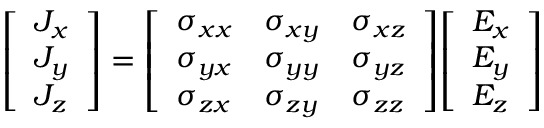Convert formula to latex. <formula><loc_0><loc_0><loc_500><loc_500>{ \left [ \begin{array} { l } { J _ { x } } \\ { J _ { y } } \\ { J _ { z } } \end{array} \right ] } = { \left [ \begin{array} { l l l } { \sigma _ { x x } } & { \sigma _ { x y } } & { \sigma _ { x z } } \\ { \sigma _ { y x } } & { \sigma _ { y y } } & { \sigma _ { y z } } \\ { \sigma _ { z x } } & { \sigma _ { z y } } & { \sigma _ { z z } } \end{array} \right ] } { \left [ \begin{array} { l } { E _ { x } } \\ { E _ { y } } \\ { E _ { z } } \end{array} \right ] }</formula> 